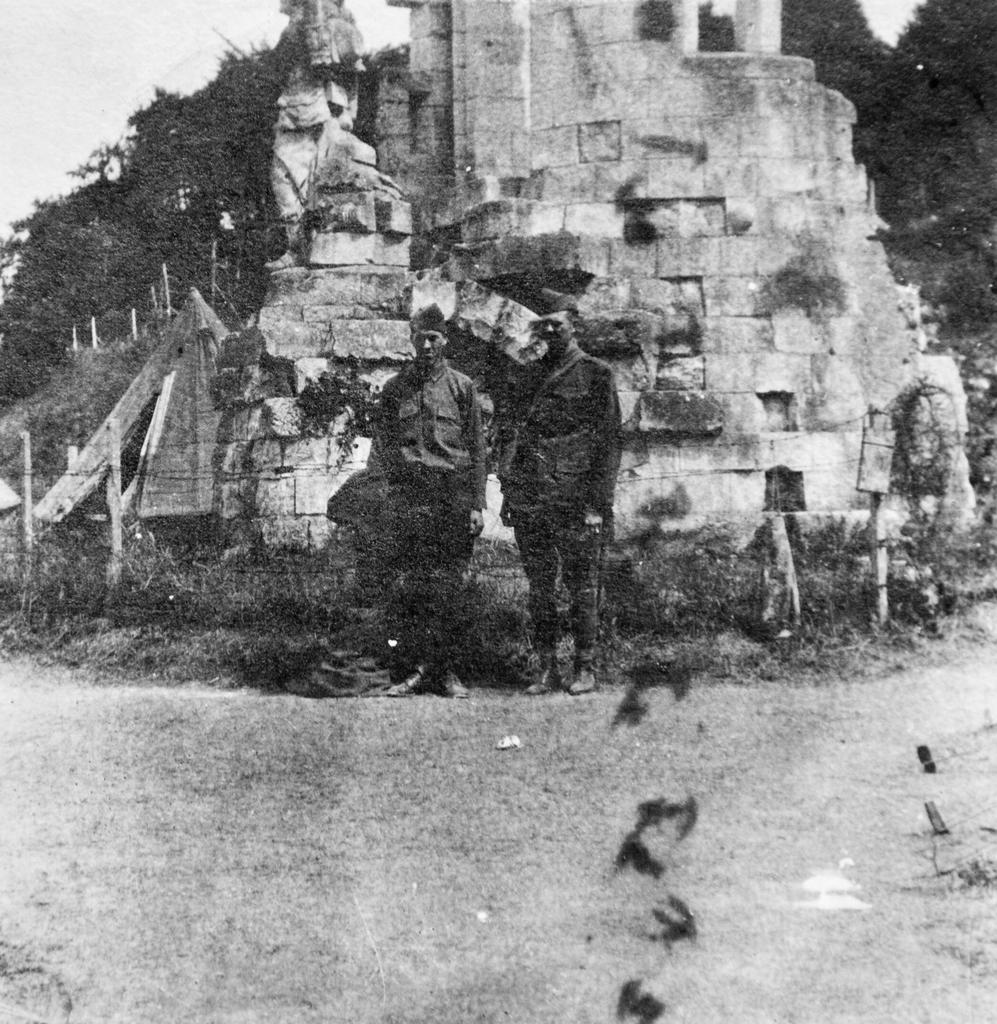How many people are in the picture? There are two men in the picture. What are the men wearing on their heads? The men are wearing caps. Where are the men standing? The men are standing on the ground. What can be seen in the background of the picture? There is a fort and trees in the picture. What is the color scheme of the picture? The picture is black and white. What type of work are the men doing in the picture? The provided facts do not mention any work being done by the men in the picture. Are the two men related in the picture? The provided facts do not mention any relation between the two men in the picture. 